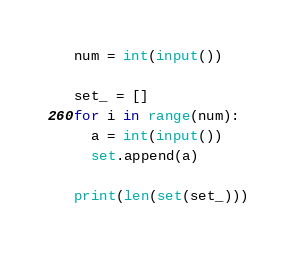<code> <loc_0><loc_0><loc_500><loc_500><_Python_>num = int(input())

set_ = []
for i in range(num):
  a = int(input())
  set.append(a)
  
print(len(set(set_)))
  </code> 